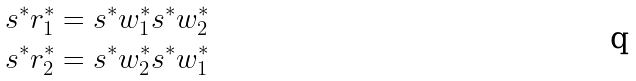Convert formula to latex. <formula><loc_0><loc_0><loc_500><loc_500>s ^ { * } r ^ { * } _ { 1 } & = s ^ { * } w ^ { * } _ { 1 } s ^ { * } w ^ { * } _ { 2 } \\ s ^ { * } r ^ { * } _ { 2 } & = s ^ { * } w ^ { * } _ { 2 } s ^ { * } w ^ { * } _ { 1 }</formula> 